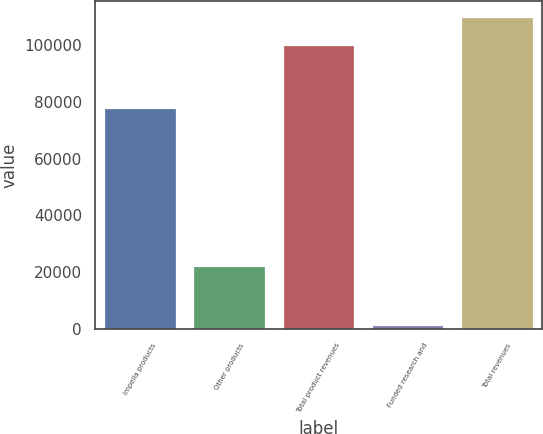Convert chart to OTSL. <chart><loc_0><loc_0><loc_500><loc_500><bar_chart><fcel>Impella products<fcel>Other products<fcel>Total product revenues<fcel>Funded research and<fcel>Total revenues<nl><fcel>77747<fcel>22090<fcel>99837<fcel>1314<fcel>109821<nl></chart> 